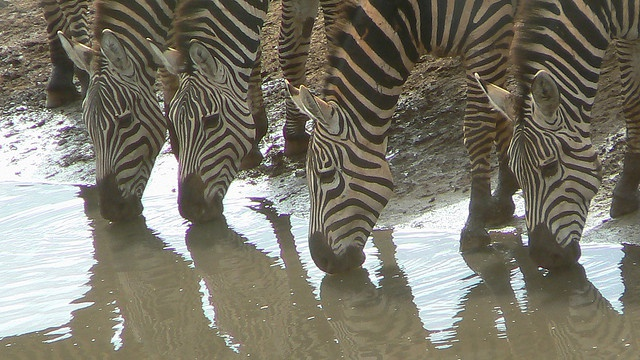Describe the objects in this image and their specific colors. I can see zebra in gray, black, and darkgreen tones, zebra in gray, black, and darkgreen tones, zebra in gray and black tones, zebra in gray and black tones, and zebra in gray and black tones in this image. 